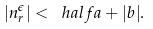Convert formula to latex. <formula><loc_0><loc_0><loc_500><loc_500>| n _ { r } ^ { \epsilon } | < \ h a l f a + | b | .</formula> 